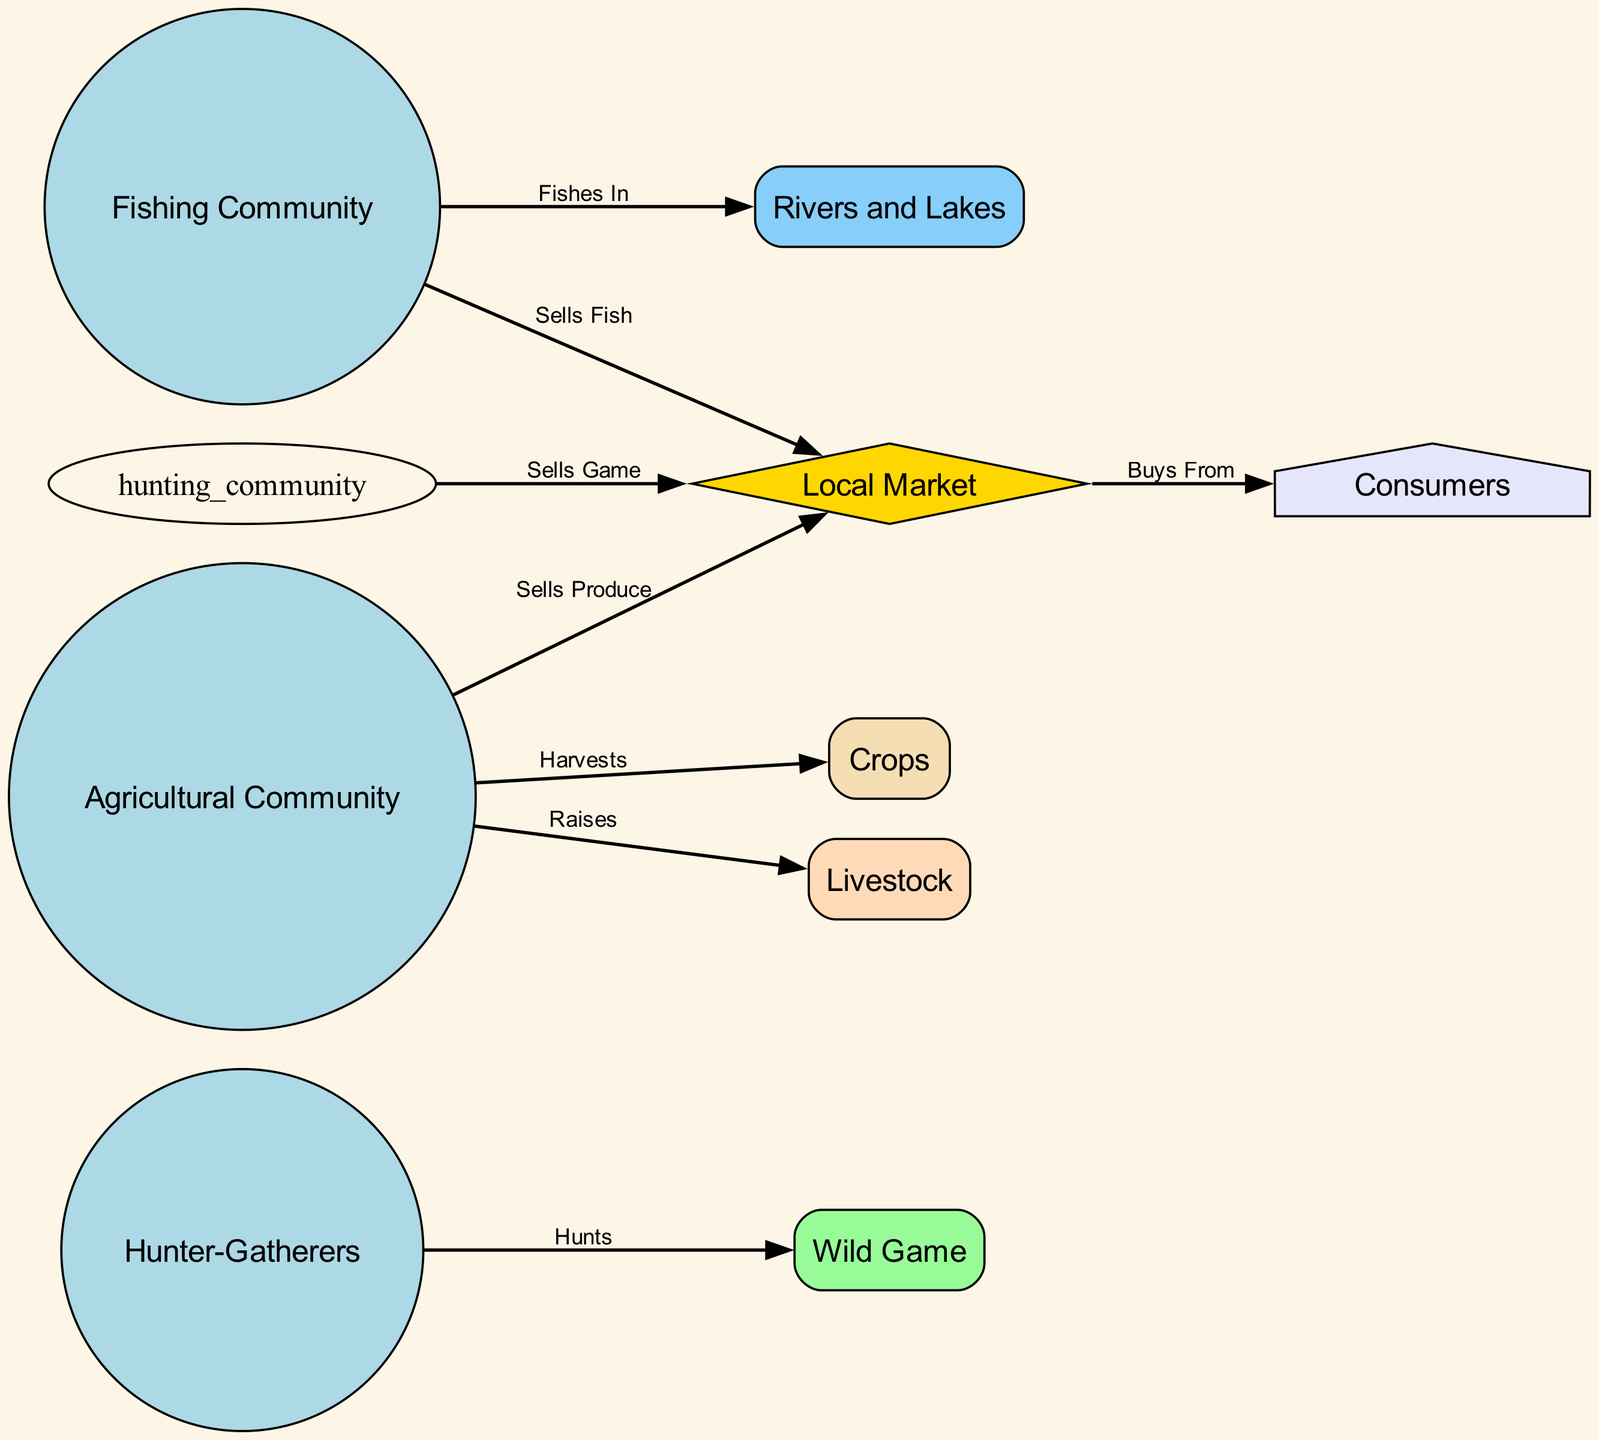What are the three types of communities represented in the diagram? The diagram identifies three types of communities: Hunter-Gatherers, Fishing Community, and Agricultural Community. Each represents a distinct group participating in the local food chain.
Answer: Hunter-Gatherers, Fishing Community, Agricultural Community How many nodes are present in the diagram? The total number of nodes can be counted: there are 8 nodes listed, representing various elements in the food chain such as communities, resources, and market.
Answer: 8 What does the Agricultural Community sell? According to the diagram, the Agricultural Community sells produce, which includes crops and livestock raised by them, at the local market.
Answer: Sells Produce Which community sells fish? The diagram indicates that the Fishing Community is responsible for selling fish to the local market, as shown by the directed edge from that community to the market node.
Answer: Fishing Community How many edges are there leading to Consumers? By examining the diagram, we see that there is only one direct edge from the Local Market to Consumers, indicating that all sales to consumers are from this market alone.
Answer: 1 What resource does the Fisheries Community fish in? The diagram specifies that the Fishing Community fishes in Rivers and Lakes, which is a direct relationship illustrated by the connecting edge in the diagram.
Answer: Rivers and Lakes Which community raises livestock? According to the edges in the diagram, only the Agricultural Community raises livestock, which is represented directly connected with the relevant edge.
Answer: Agricultural Community What type of game do Hunter-Gatherers hunt? The Hunter-Gatherers hunt Wild Game, as indicated in the diagram by the directed edge leading from the Hunter-Gatherers node to the Wild Game node.
Answer: Wild Game 